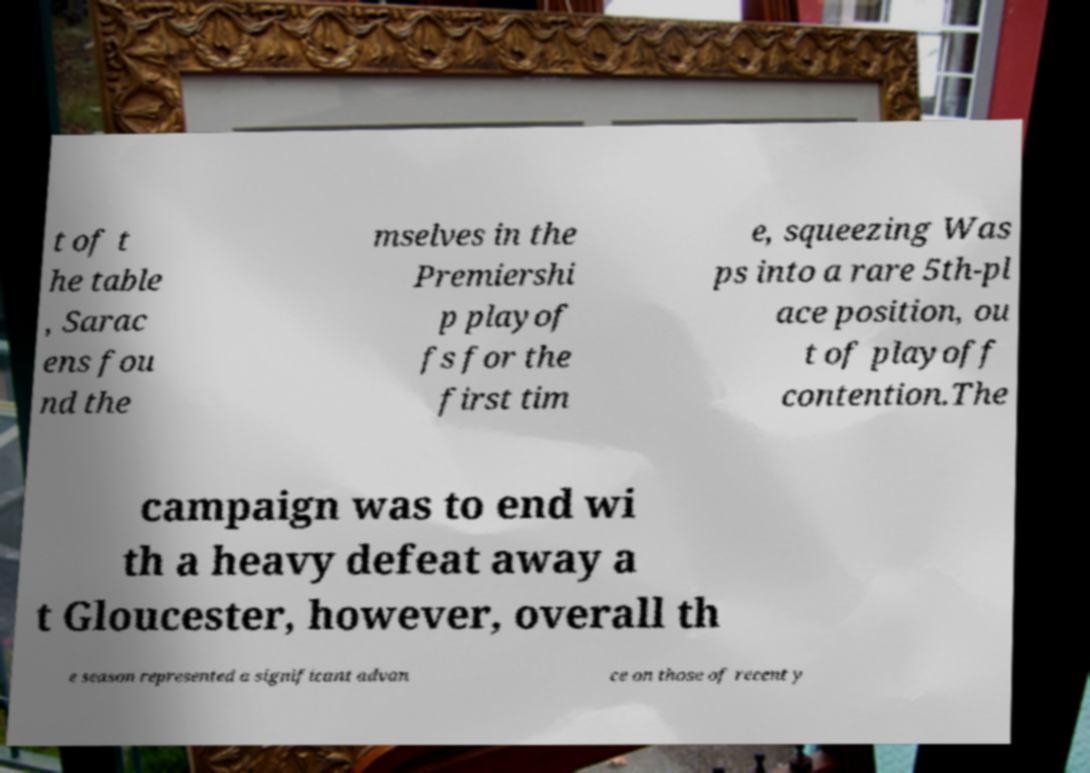Please read and relay the text visible in this image. What does it say? t of t he table , Sarac ens fou nd the mselves in the Premiershi p playof fs for the first tim e, squeezing Was ps into a rare 5th-pl ace position, ou t of playoff contention.The campaign was to end wi th a heavy defeat away a t Gloucester, however, overall th e season represented a significant advan ce on those of recent y 